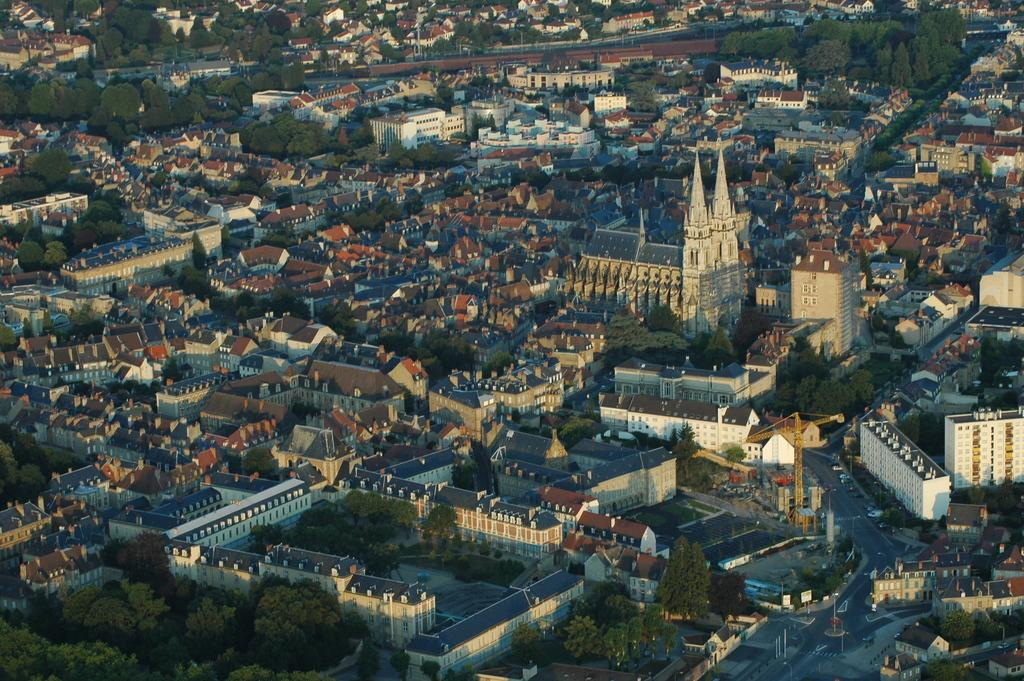What type of natural elements can be seen in the image? There are trees in the image. What type of man-made structures can be seen in the image? There are houses, buildings, and towers in the image. What type of transportation is visible in the image? There are vehicles on the road in the image. What type of lighting is present in the image? There are street lights in the image. What time of day is the image likely taken? The image is likely taken during the day, as there is no indication of darkness or artificial lighting. What type of acoustics can be heard in the image? There is no sound present in the image, so it is not possible to determine the acoustics. What type of cloud is present in the image? There is no cloud present in the image; it is likely taken during the day, as mentioned earlier. 